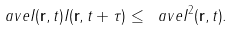Convert formula to latex. <formula><loc_0><loc_0><loc_500><loc_500>\ a v e { I ( { \mathbf r } , t ) I ( { \mathbf r } , t + \tau ) } \leq \ a v e { I ^ { 2 } ( { \mathbf r } , t ) } .</formula> 